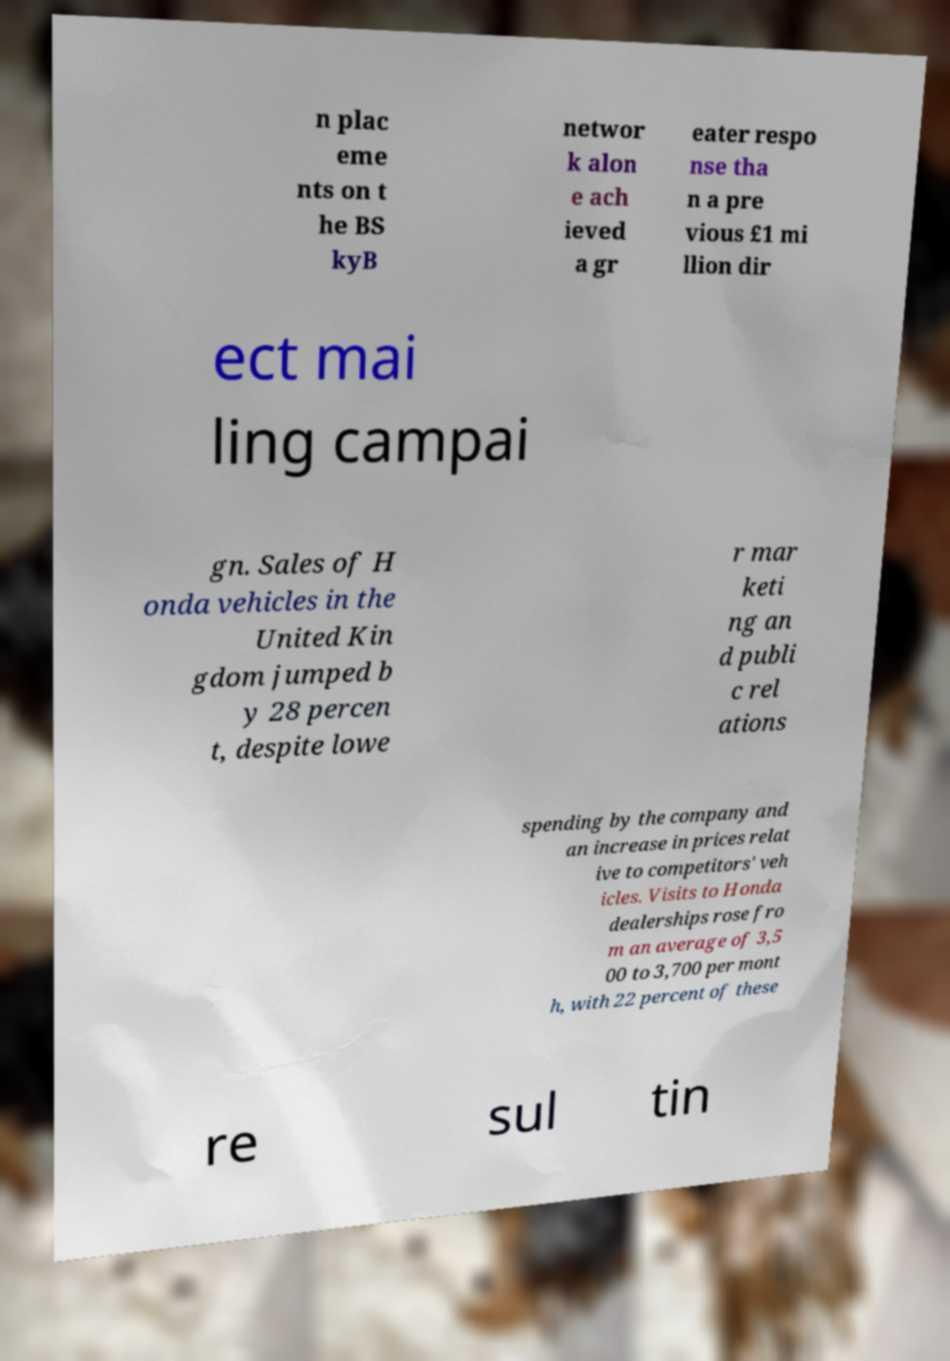I need the written content from this picture converted into text. Can you do that? n plac eme nts on t he BS kyB networ k alon e ach ieved a gr eater respo nse tha n a pre vious £1 mi llion dir ect mai ling campai gn. Sales of H onda vehicles in the United Kin gdom jumped b y 28 percen t, despite lowe r mar keti ng an d publi c rel ations spending by the company and an increase in prices relat ive to competitors' veh icles. Visits to Honda dealerships rose fro m an average of 3,5 00 to 3,700 per mont h, with 22 percent of these re sul tin 